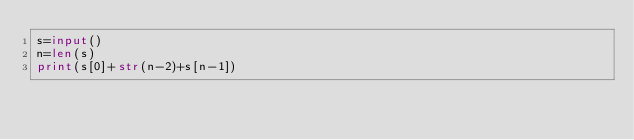Convert code to text. <code><loc_0><loc_0><loc_500><loc_500><_Python_>s=input()
n=len(s)
print(s[0]+str(n-2)+s[n-1])</code> 